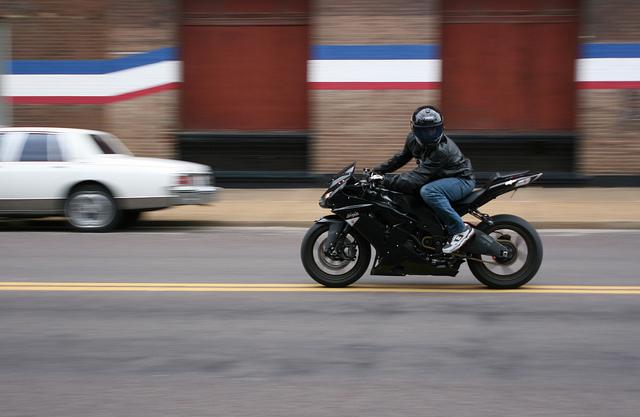Which former country had a flag which looks similar to these banners?

Choices:
A) czechoslovakia
B) zaire
C) yugoslavia
D) rhodesia yugoslavia 